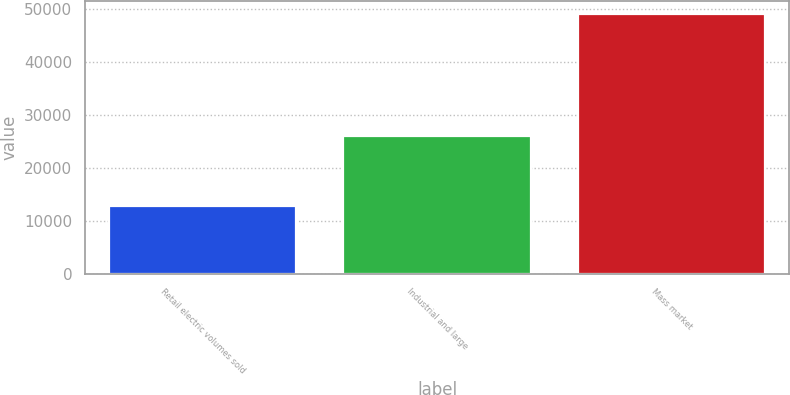Convert chart. <chart><loc_0><loc_0><loc_500><loc_500><bar_chart><fcel>Retail electric volumes sold<fcel>Industrial and large<fcel>Mass market<nl><fcel>12723<fcel>26009<fcel>49094<nl></chart> 